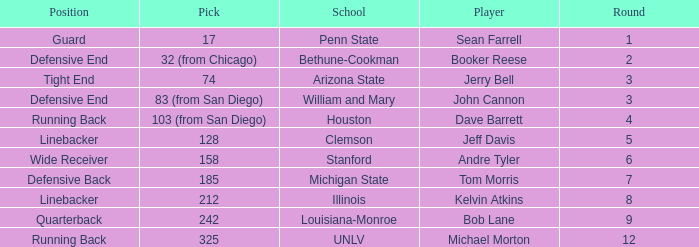In which round was tom morris selected? 1.0. 